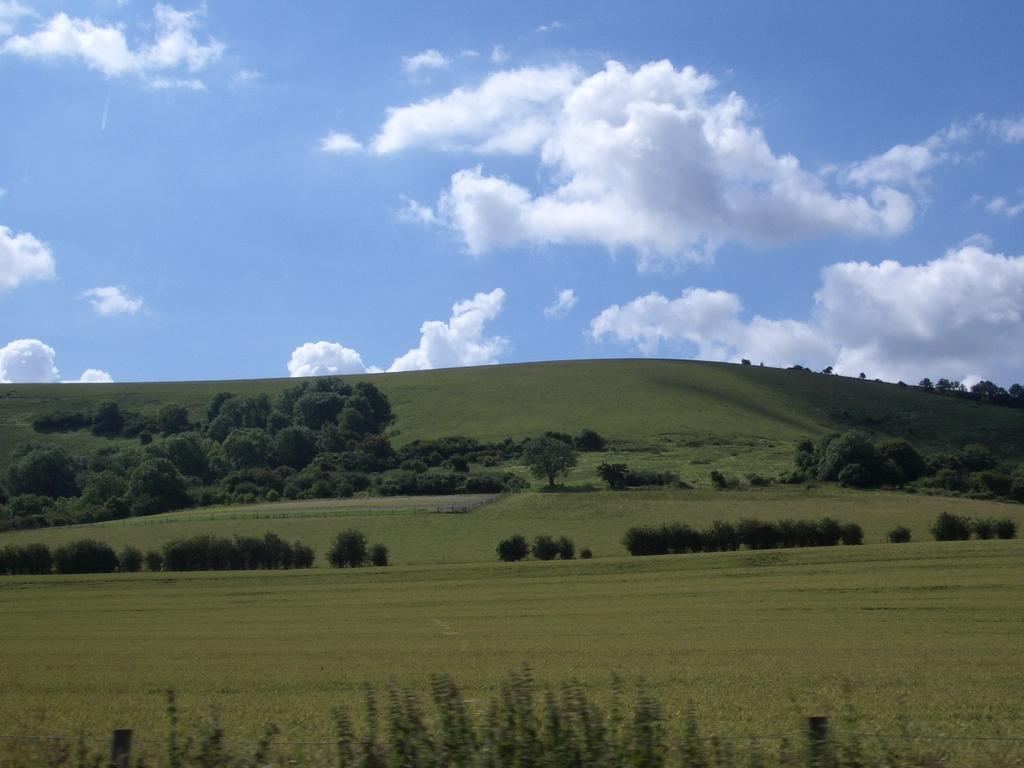What type of vegetation can be seen in the image? There is grass, plants, and trees visible in the image. What part of the natural environment is visible in the image? The sky is visible in the image. What can be seen in the sky in the image? Clouds are present in the sky. Where is the servant standing in the image? There is no servant present in the image. What type of space object can be seen in the image? There are no space objects present in the image; it features natural elements such as grass, plants, trees, and the sky. Can you tell me how many chairs are visible in the image? There are no chairs present in the image. 